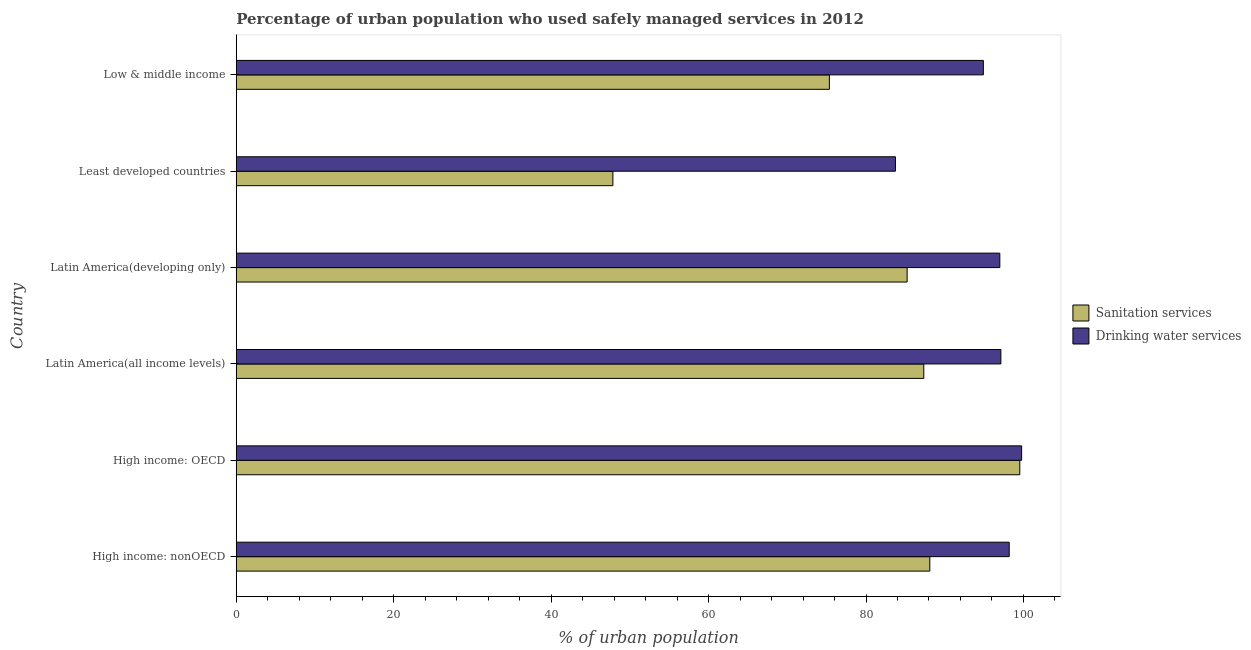How many different coloured bars are there?
Offer a terse response. 2. How many bars are there on the 6th tick from the bottom?
Offer a terse response. 2. What is the label of the 6th group of bars from the top?
Your response must be concise. High income: nonOECD. What is the percentage of urban population who used drinking water services in High income: OECD?
Provide a short and direct response. 99.77. Across all countries, what is the maximum percentage of urban population who used sanitation services?
Your response must be concise. 99.54. Across all countries, what is the minimum percentage of urban population who used drinking water services?
Provide a short and direct response. 83.74. In which country was the percentage of urban population who used sanitation services maximum?
Provide a short and direct response. High income: OECD. In which country was the percentage of urban population who used sanitation services minimum?
Give a very brief answer. Least developed countries. What is the total percentage of urban population who used sanitation services in the graph?
Provide a short and direct response. 483.4. What is the difference between the percentage of urban population who used drinking water services in Latin America(developing only) and that in Low & middle income?
Ensure brevity in your answer.  2.09. What is the difference between the percentage of urban population who used sanitation services in Low & middle income and the percentage of urban population who used drinking water services in Latin America(all income levels)?
Ensure brevity in your answer.  -21.79. What is the average percentage of urban population who used sanitation services per country?
Your response must be concise. 80.57. What is the difference between the percentage of urban population who used drinking water services and percentage of urban population who used sanitation services in Latin America(all income levels)?
Make the answer very short. 9.79. In how many countries, is the percentage of urban population who used drinking water services greater than 88 %?
Give a very brief answer. 5. What is the ratio of the percentage of urban population who used sanitation services in Least developed countries to that in Low & middle income?
Make the answer very short. 0.64. Is the difference between the percentage of urban population who used sanitation services in Latin America(all income levels) and Low & middle income greater than the difference between the percentage of urban population who used drinking water services in Latin America(all income levels) and Low & middle income?
Your response must be concise. Yes. What is the difference between the highest and the second highest percentage of urban population who used sanitation services?
Ensure brevity in your answer.  11.43. What is the difference between the highest and the lowest percentage of urban population who used drinking water services?
Your answer should be compact. 16.03. In how many countries, is the percentage of urban population who used drinking water services greater than the average percentage of urban population who used drinking water services taken over all countries?
Make the answer very short. 4. What does the 2nd bar from the top in Latin America(all income levels) represents?
Ensure brevity in your answer.  Sanitation services. What does the 1st bar from the bottom in Latin America(developing only) represents?
Ensure brevity in your answer.  Sanitation services. How many bars are there?
Offer a terse response. 12. How many countries are there in the graph?
Your answer should be compact. 6. What is the difference between two consecutive major ticks on the X-axis?
Give a very brief answer. 20. Are the values on the major ticks of X-axis written in scientific E-notation?
Keep it short and to the point. No. How many legend labels are there?
Offer a very short reply. 2. What is the title of the graph?
Your answer should be very brief. Percentage of urban population who used safely managed services in 2012. What is the label or title of the X-axis?
Give a very brief answer. % of urban population. What is the % of urban population in Sanitation services in High income: nonOECD?
Make the answer very short. 88.11. What is the % of urban population of Drinking water services in High income: nonOECD?
Provide a short and direct response. 98.19. What is the % of urban population of Sanitation services in High income: OECD?
Offer a terse response. 99.54. What is the % of urban population of Drinking water services in High income: OECD?
Provide a succinct answer. 99.77. What is the % of urban population in Sanitation services in Latin America(all income levels)?
Give a very brief answer. 87.34. What is the % of urban population in Drinking water services in Latin America(all income levels)?
Your answer should be compact. 97.13. What is the % of urban population in Sanitation services in Latin America(developing only)?
Ensure brevity in your answer.  85.23. What is the % of urban population of Drinking water services in Latin America(developing only)?
Keep it short and to the point. 97. What is the % of urban population in Sanitation services in Least developed countries?
Keep it short and to the point. 47.85. What is the % of urban population of Drinking water services in Least developed countries?
Give a very brief answer. 83.74. What is the % of urban population in Sanitation services in Low & middle income?
Offer a terse response. 75.35. What is the % of urban population in Drinking water services in Low & middle income?
Keep it short and to the point. 94.91. Across all countries, what is the maximum % of urban population of Sanitation services?
Provide a succinct answer. 99.54. Across all countries, what is the maximum % of urban population of Drinking water services?
Your answer should be compact. 99.77. Across all countries, what is the minimum % of urban population of Sanitation services?
Keep it short and to the point. 47.85. Across all countries, what is the minimum % of urban population of Drinking water services?
Make the answer very short. 83.74. What is the total % of urban population of Sanitation services in the graph?
Provide a short and direct response. 483.4. What is the total % of urban population of Drinking water services in the graph?
Offer a terse response. 570.75. What is the difference between the % of urban population in Sanitation services in High income: nonOECD and that in High income: OECD?
Ensure brevity in your answer.  -11.43. What is the difference between the % of urban population in Drinking water services in High income: nonOECD and that in High income: OECD?
Your answer should be compact. -1.58. What is the difference between the % of urban population of Sanitation services in High income: nonOECD and that in Latin America(all income levels)?
Offer a terse response. 0.76. What is the difference between the % of urban population in Drinking water services in High income: nonOECD and that in Latin America(all income levels)?
Give a very brief answer. 1.06. What is the difference between the % of urban population of Sanitation services in High income: nonOECD and that in Latin America(developing only)?
Make the answer very short. 2.88. What is the difference between the % of urban population in Drinking water services in High income: nonOECD and that in Latin America(developing only)?
Provide a short and direct response. 1.19. What is the difference between the % of urban population in Sanitation services in High income: nonOECD and that in Least developed countries?
Make the answer very short. 40.26. What is the difference between the % of urban population of Drinking water services in High income: nonOECD and that in Least developed countries?
Give a very brief answer. 14.45. What is the difference between the % of urban population of Sanitation services in High income: nonOECD and that in Low & middle income?
Keep it short and to the point. 12.76. What is the difference between the % of urban population of Drinking water services in High income: nonOECD and that in Low & middle income?
Your answer should be compact. 3.28. What is the difference between the % of urban population in Sanitation services in High income: OECD and that in Latin America(all income levels)?
Offer a terse response. 12.2. What is the difference between the % of urban population in Drinking water services in High income: OECD and that in Latin America(all income levels)?
Your answer should be compact. 2.64. What is the difference between the % of urban population of Sanitation services in High income: OECD and that in Latin America(developing only)?
Keep it short and to the point. 14.31. What is the difference between the % of urban population of Drinking water services in High income: OECD and that in Latin America(developing only)?
Offer a terse response. 2.77. What is the difference between the % of urban population of Sanitation services in High income: OECD and that in Least developed countries?
Offer a terse response. 51.69. What is the difference between the % of urban population of Drinking water services in High income: OECD and that in Least developed countries?
Make the answer very short. 16.03. What is the difference between the % of urban population of Sanitation services in High income: OECD and that in Low & middle income?
Ensure brevity in your answer.  24.19. What is the difference between the % of urban population in Drinking water services in High income: OECD and that in Low & middle income?
Provide a succinct answer. 4.86. What is the difference between the % of urban population in Sanitation services in Latin America(all income levels) and that in Latin America(developing only)?
Offer a terse response. 2.12. What is the difference between the % of urban population of Drinking water services in Latin America(all income levels) and that in Latin America(developing only)?
Make the answer very short. 0.13. What is the difference between the % of urban population in Sanitation services in Latin America(all income levels) and that in Least developed countries?
Your answer should be very brief. 39.49. What is the difference between the % of urban population of Drinking water services in Latin America(all income levels) and that in Least developed countries?
Offer a terse response. 13.39. What is the difference between the % of urban population in Sanitation services in Latin America(all income levels) and that in Low & middle income?
Provide a short and direct response. 11.99. What is the difference between the % of urban population in Drinking water services in Latin America(all income levels) and that in Low & middle income?
Your answer should be very brief. 2.22. What is the difference between the % of urban population of Sanitation services in Latin America(developing only) and that in Least developed countries?
Your answer should be very brief. 37.38. What is the difference between the % of urban population of Drinking water services in Latin America(developing only) and that in Least developed countries?
Offer a terse response. 13.26. What is the difference between the % of urban population in Sanitation services in Latin America(developing only) and that in Low & middle income?
Keep it short and to the point. 9.88. What is the difference between the % of urban population in Drinking water services in Latin America(developing only) and that in Low & middle income?
Provide a short and direct response. 2.09. What is the difference between the % of urban population of Sanitation services in Least developed countries and that in Low & middle income?
Your response must be concise. -27.5. What is the difference between the % of urban population of Drinking water services in Least developed countries and that in Low & middle income?
Keep it short and to the point. -11.17. What is the difference between the % of urban population in Sanitation services in High income: nonOECD and the % of urban population in Drinking water services in High income: OECD?
Give a very brief answer. -11.66. What is the difference between the % of urban population of Sanitation services in High income: nonOECD and the % of urban population of Drinking water services in Latin America(all income levels)?
Offer a very short reply. -9.03. What is the difference between the % of urban population of Sanitation services in High income: nonOECD and the % of urban population of Drinking water services in Latin America(developing only)?
Keep it short and to the point. -8.9. What is the difference between the % of urban population in Sanitation services in High income: nonOECD and the % of urban population in Drinking water services in Least developed countries?
Offer a very short reply. 4.37. What is the difference between the % of urban population in Sanitation services in High income: nonOECD and the % of urban population in Drinking water services in Low & middle income?
Ensure brevity in your answer.  -6.8. What is the difference between the % of urban population of Sanitation services in High income: OECD and the % of urban population of Drinking water services in Latin America(all income levels)?
Your answer should be very brief. 2.4. What is the difference between the % of urban population in Sanitation services in High income: OECD and the % of urban population in Drinking water services in Latin America(developing only)?
Offer a terse response. 2.54. What is the difference between the % of urban population of Sanitation services in High income: OECD and the % of urban population of Drinking water services in Least developed countries?
Your response must be concise. 15.8. What is the difference between the % of urban population of Sanitation services in High income: OECD and the % of urban population of Drinking water services in Low & middle income?
Your answer should be compact. 4.63. What is the difference between the % of urban population in Sanitation services in Latin America(all income levels) and the % of urban population in Drinking water services in Latin America(developing only)?
Ensure brevity in your answer.  -9.66. What is the difference between the % of urban population of Sanitation services in Latin America(all income levels) and the % of urban population of Drinking water services in Least developed countries?
Your answer should be very brief. 3.6. What is the difference between the % of urban population in Sanitation services in Latin America(all income levels) and the % of urban population in Drinking water services in Low & middle income?
Keep it short and to the point. -7.57. What is the difference between the % of urban population in Sanitation services in Latin America(developing only) and the % of urban population in Drinking water services in Least developed countries?
Make the answer very short. 1.49. What is the difference between the % of urban population of Sanitation services in Latin America(developing only) and the % of urban population of Drinking water services in Low & middle income?
Provide a succinct answer. -9.68. What is the difference between the % of urban population in Sanitation services in Least developed countries and the % of urban population in Drinking water services in Low & middle income?
Keep it short and to the point. -47.06. What is the average % of urban population in Sanitation services per country?
Offer a terse response. 80.57. What is the average % of urban population in Drinking water services per country?
Your answer should be compact. 95.12. What is the difference between the % of urban population of Sanitation services and % of urban population of Drinking water services in High income: nonOECD?
Provide a short and direct response. -10.09. What is the difference between the % of urban population in Sanitation services and % of urban population in Drinking water services in High income: OECD?
Ensure brevity in your answer.  -0.23. What is the difference between the % of urban population of Sanitation services and % of urban population of Drinking water services in Latin America(all income levels)?
Give a very brief answer. -9.79. What is the difference between the % of urban population in Sanitation services and % of urban population in Drinking water services in Latin America(developing only)?
Ensure brevity in your answer.  -11.78. What is the difference between the % of urban population in Sanitation services and % of urban population in Drinking water services in Least developed countries?
Make the answer very short. -35.89. What is the difference between the % of urban population in Sanitation services and % of urban population in Drinking water services in Low & middle income?
Your answer should be compact. -19.56. What is the ratio of the % of urban population of Sanitation services in High income: nonOECD to that in High income: OECD?
Make the answer very short. 0.89. What is the ratio of the % of urban population in Drinking water services in High income: nonOECD to that in High income: OECD?
Give a very brief answer. 0.98. What is the ratio of the % of urban population in Sanitation services in High income: nonOECD to that in Latin America(all income levels)?
Your answer should be compact. 1.01. What is the ratio of the % of urban population in Drinking water services in High income: nonOECD to that in Latin America(all income levels)?
Offer a very short reply. 1.01. What is the ratio of the % of urban population in Sanitation services in High income: nonOECD to that in Latin America(developing only)?
Provide a short and direct response. 1.03. What is the ratio of the % of urban population of Drinking water services in High income: nonOECD to that in Latin America(developing only)?
Offer a terse response. 1.01. What is the ratio of the % of urban population in Sanitation services in High income: nonOECD to that in Least developed countries?
Your response must be concise. 1.84. What is the ratio of the % of urban population of Drinking water services in High income: nonOECD to that in Least developed countries?
Keep it short and to the point. 1.17. What is the ratio of the % of urban population of Sanitation services in High income: nonOECD to that in Low & middle income?
Offer a terse response. 1.17. What is the ratio of the % of urban population in Drinking water services in High income: nonOECD to that in Low & middle income?
Keep it short and to the point. 1.03. What is the ratio of the % of urban population in Sanitation services in High income: OECD to that in Latin America(all income levels)?
Make the answer very short. 1.14. What is the ratio of the % of urban population in Drinking water services in High income: OECD to that in Latin America(all income levels)?
Offer a terse response. 1.03. What is the ratio of the % of urban population in Sanitation services in High income: OECD to that in Latin America(developing only)?
Offer a terse response. 1.17. What is the ratio of the % of urban population in Drinking water services in High income: OECD to that in Latin America(developing only)?
Offer a terse response. 1.03. What is the ratio of the % of urban population in Sanitation services in High income: OECD to that in Least developed countries?
Provide a short and direct response. 2.08. What is the ratio of the % of urban population of Drinking water services in High income: OECD to that in Least developed countries?
Keep it short and to the point. 1.19. What is the ratio of the % of urban population of Sanitation services in High income: OECD to that in Low & middle income?
Offer a terse response. 1.32. What is the ratio of the % of urban population in Drinking water services in High income: OECD to that in Low & middle income?
Provide a short and direct response. 1.05. What is the ratio of the % of urban population of Sanitation services in Latin America(all income levels) to that in Latin America(developing only)?
Ensure brevity in your answer.  1.02. What is the ratio of the % of urban population in Drinking water services in Latin America(all income levels) to that in Latin America(developing only)?
Your answer should be very brief. 1. What is the ratio of the % of urban population in Sanitation services in Latin America(all income levels) to that in Least developed countries?
Offer a terse response. 1.83. What is the ratio of the % of urban population in Drinking water services in Latin America(all income levels) to that in Least developed countries?
Your answer should be very brief. 1.16. What is the ratio of the % of urban population of Sanitation services in Latin America(all income levels) to that in Low & middle income?
Provide a succinct answer. 1.16. What is the ratio of the % of urban population in Drinking water services in Latin America(all income levels) to that in Low & middle income?
Ensure brevity in your answer.  1.02. What is the ratio of the % of urban population in Sanitation services in Latin America(developing only) to that in Least developed countries?
Offer a terse response. 1.78. What is the ratio of the % of urban population of Drinking water services in Latin America(developing only) to that in Least developed countries?
Your response must be concise. 1.16. What is the ratio of the % of urban population in Sanitation services in Latin America(developing only) to that in Low & middle income?
Your answer should be very brief. 1.13. What is the ratio of the % of urban population in Sanitation services in Least developed countries to that in Low & middle income?
Make the answer very short. 0.64. What is the ratio of the % of urban population of Drinking water services in Least developed countries to that in Low & middle income?
Your answer should be very brief. 0.88. What is the difference between the highest and the second highest % of urban population of Sanitation services?
Offer a terse response. 11.43. What is the difference between the highest and the second highest % of urban population in Drinking water services?
Your response must be concise. 1.58. What is the difference between the highest and the lowest % of urban population of Sanitation services?
Your answer should be compact. 51.69. What is the difference between the highest and the lowest % of urban population in Drinking water services?
Your answer should be compact. 16.03. 